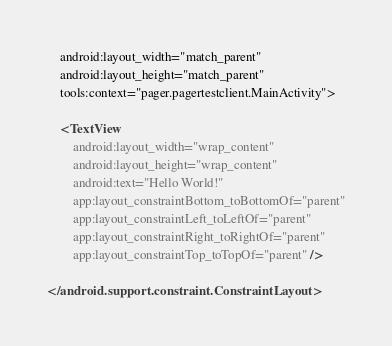Convert code to text. <code><loc_0><loc_0><loc_500><loc_500><_XML_>    android:layout_width="match_parent"
    android:layout_height="match_parent"
    tools:context="pager.pagertestclient.MainActivity">

    <TextView
        android:layout_width="wrap_content"
        android:layout_height="wrap_content"
        android:text="Hello World!"
        app:layout_constraintBottom_toBottomOf="parent"
        app:layout_constraintLeft_toLeftOf="parent"
        app:layout_constraintRight_toRightOf="parent"
        app:layout_constraintTop_toTopOf="parent" />

</android.support.constraint.ConstraintLayout>
</code> 